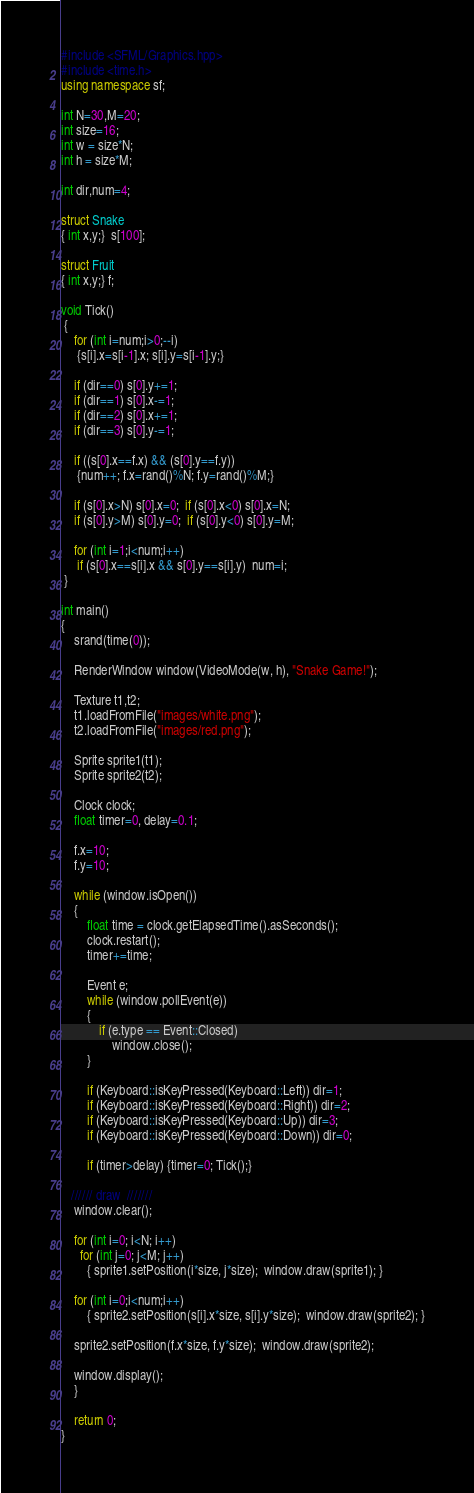Convert code to text. <code><loc_0><loc_0><loc_500><loc_500><_C++_>#include <SFML/Graphics.hpp>
#include <time.h>
using namespace sf;

int N=30,M=20;
int size=16;
int w = size*N;
int h = size*M;

int dir,num=4;

struct Snake 
{ int x,y;}  s[100];

struct Fruit
{ int x,y;} f;

void Tick()
 {
    for (int i=num;i>0;--i)
     {s[i].x=s[i-1].x; s[i].y=s[i-1].y;}

    if (dir==0) s[0].y+=1;      
    if (dir==1) s[0].x-=1;        
    if (dir==2) s[0].x+=1;         
    if (dir==3) s[0].y-=1;   

    if ((s[0].x==f.x) && (s[0].y==f.y)) 
     {num++; f.x=rand()%N; f.y=rand()%M;}

    if (s[0].x>N) s[0].x=0;  if (s[0].x<0) s[0].x=N;
    if (s[0].y>M) s[0].y=0;  if (s[0].y<0) s[0].y=M;
 
    for (int i=1;i<num;i++)
     if (s[0].x==s[i].x && s[0].y==s[i].y)  num=i;
 }

int main()
{  
    srand(time(0));

    RenderWindow window(VideoMode(w, h), "Snake Game!");

    Texture t1,t2;
    t1.loadFromFile("images/white.png");
    t2.loadFromFile("images/red.png");

    Sprite sprite1(t1);
    Sprite sprite2(t2);

    Clock clock;
    float timer=0, delay=0.1;

    f.x=10;
    f.y=10; 
    
    while (window.isOpen())
    {
        float time = clock.getElapsedTime().asSeconds();
        clock.restart();
        timer+=time; 

        Event e;
        while (window.pollEvent(e))
        {
            if (e.type == Event::Closed)      
                window.close();
        }

        if (Keyboard::isKeyPressed(Keyboard::Left)) dir=1;   
        if (Keyboard::isKeyPressed(Keyboard::Right)) dir=2;    
        if (Keyboard::isKeyPressed(Keyboard::Up)) dir=3;
        if (Keyboard::isKeyPressed(Keyboard::Down)) dir=0;

        if (timer>delay) {timer=0; Tick();}

   ////// draw  ///////
    window.clear();

    for (int i=0; i<N; i++) 
      for (int j=0; j<M; j++) 
        { sprite1.setPosition(i*size, j*size);  window.draw(sprite1); }

    for (int i=0;i<num;i++)
        { sprite2.setPosition(s[i].x*size, s[i].y*size);  window.draw(sprite2); }
   
    sprite2.setPosition(f.x*size, f.y*size);  window.draw(sprite2);    

    window.display();
    }

    return 0;
}
</code> 